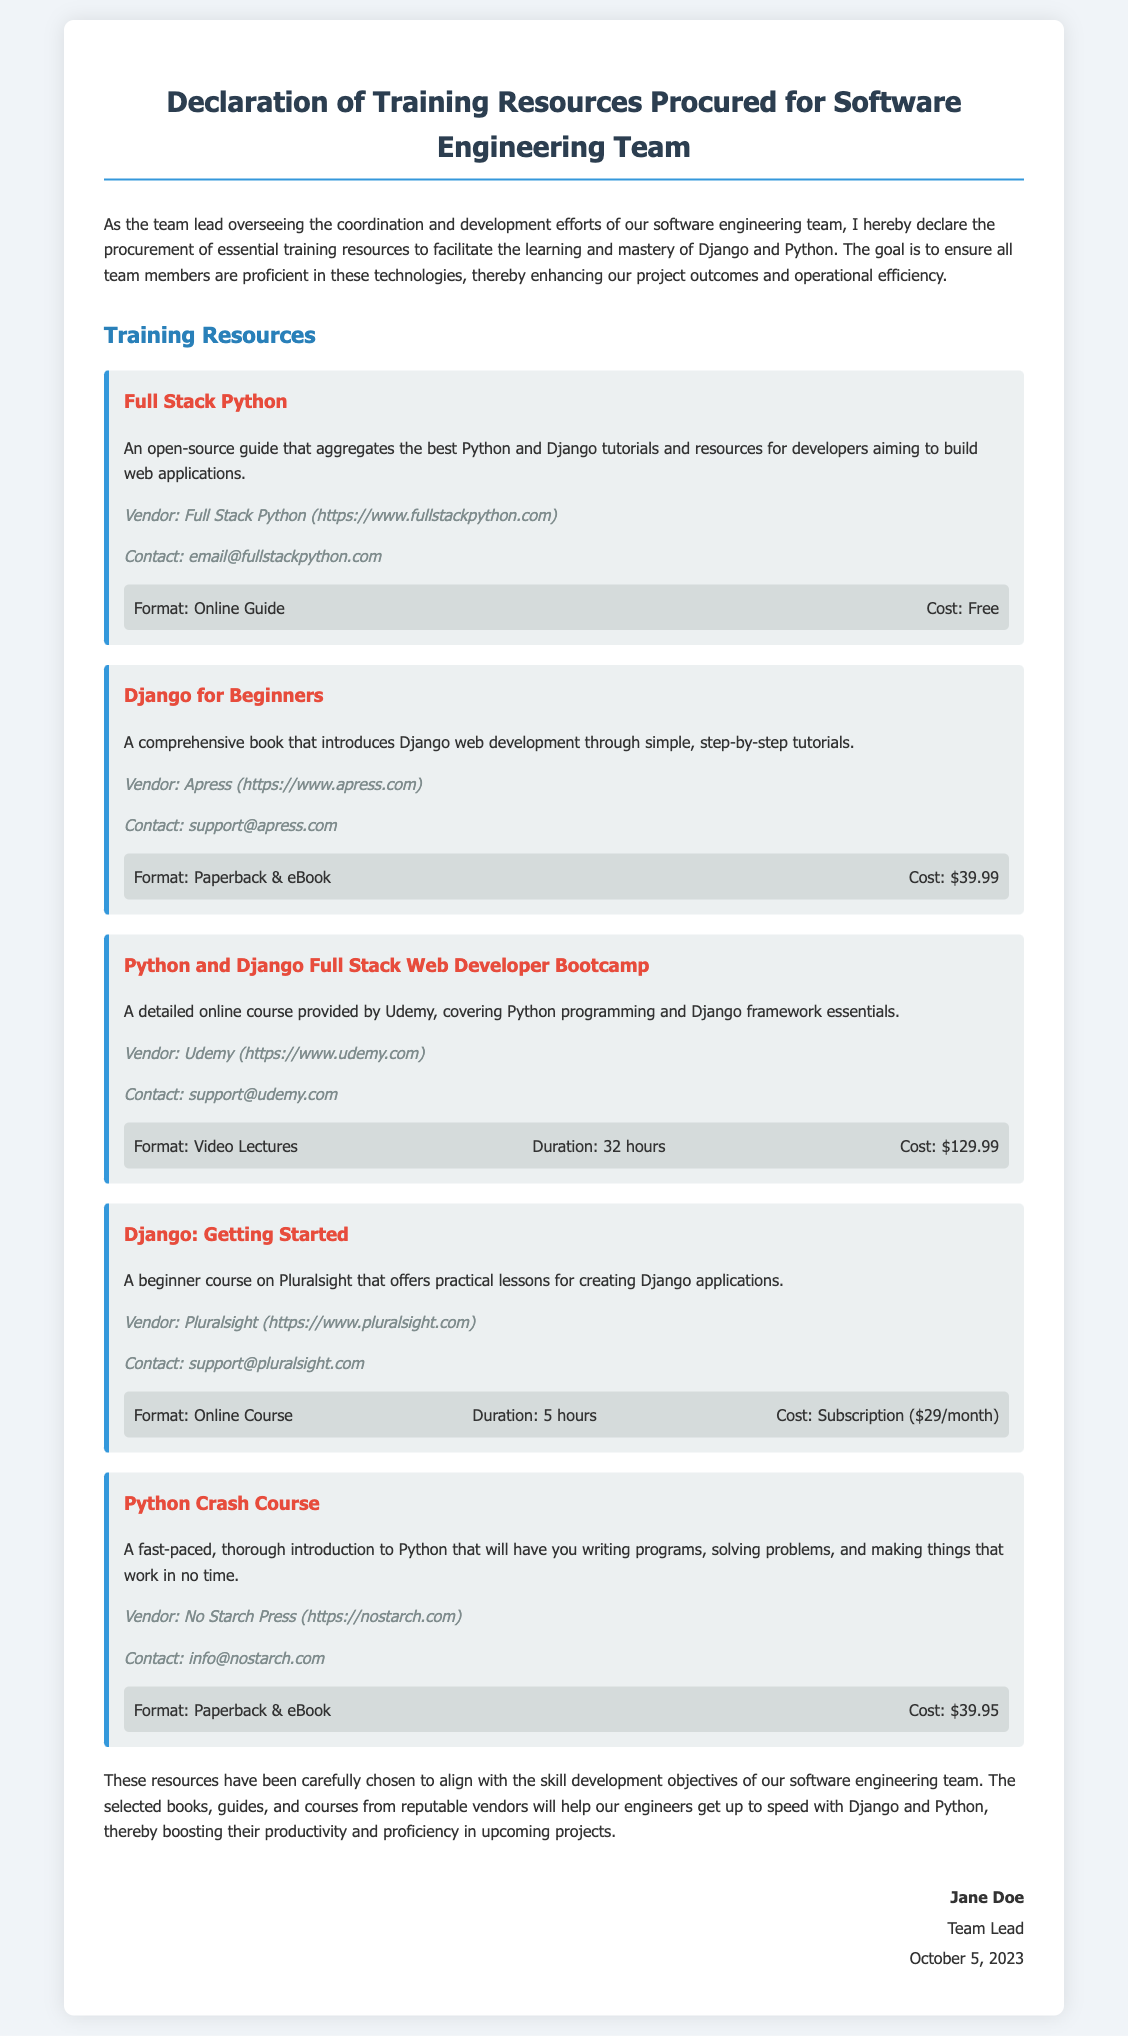What is the title of the document? The title of the document is clearly stated at the top of the rendered document.
Answer: Declaration of Training Resources Procured for Software Engineering Team Who is the vendor of "Full Stack Python"? The document provides vendor information for each training resource, including "Full Stack Python".
Answer: Full Stack Python What is the cost of "Django for Beginners"? The document lists the cost for each training resource, specifically mentioning the price of "Django for Beginners".
Answer: $39.99 How long is the "Python and Django Full Stack Web Developer Bootcamp"? The document states the duration of courses where applicable, noting the length of the bootcamp.
Answer: 32 hours What format is "Django: Getting Started" offered in? The document specifies the format for each resource, and "Django: Getting Started" is categorized under a specific format.
Answer: Online Course What is the publication year of "Python Crash Course"? The document does not clearly state a publication year, but this question encourages deeper reasoning about provided information, which may not exist.
Answer: Not mentioned How many training resources are listed in the document? By reviewing the document, one can count the number of training resources detailed throughout.
Answer: Five Who signed the declaration? The signature section shows who has formally signed the document, confirming the procurement of training resources.
Answer: Jane Doe What is the goal of procuring these resources? The initial paragraph outlines the primary goal behind the procurement of the training resources.
Answer: Mastery of Django and Python What is the contact email for Pluralsight? The vendor information section provides contact details for each resource, including the email for Pluralsight.
Answer: support@pluralsight.com 